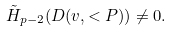Convert formula to latex. <formula><loc_0><loc_0><loc_500><loc_500>\tilde { H } _ { p - 2 } ( D ( v , < P ) ) \not = 0 .</formula> 